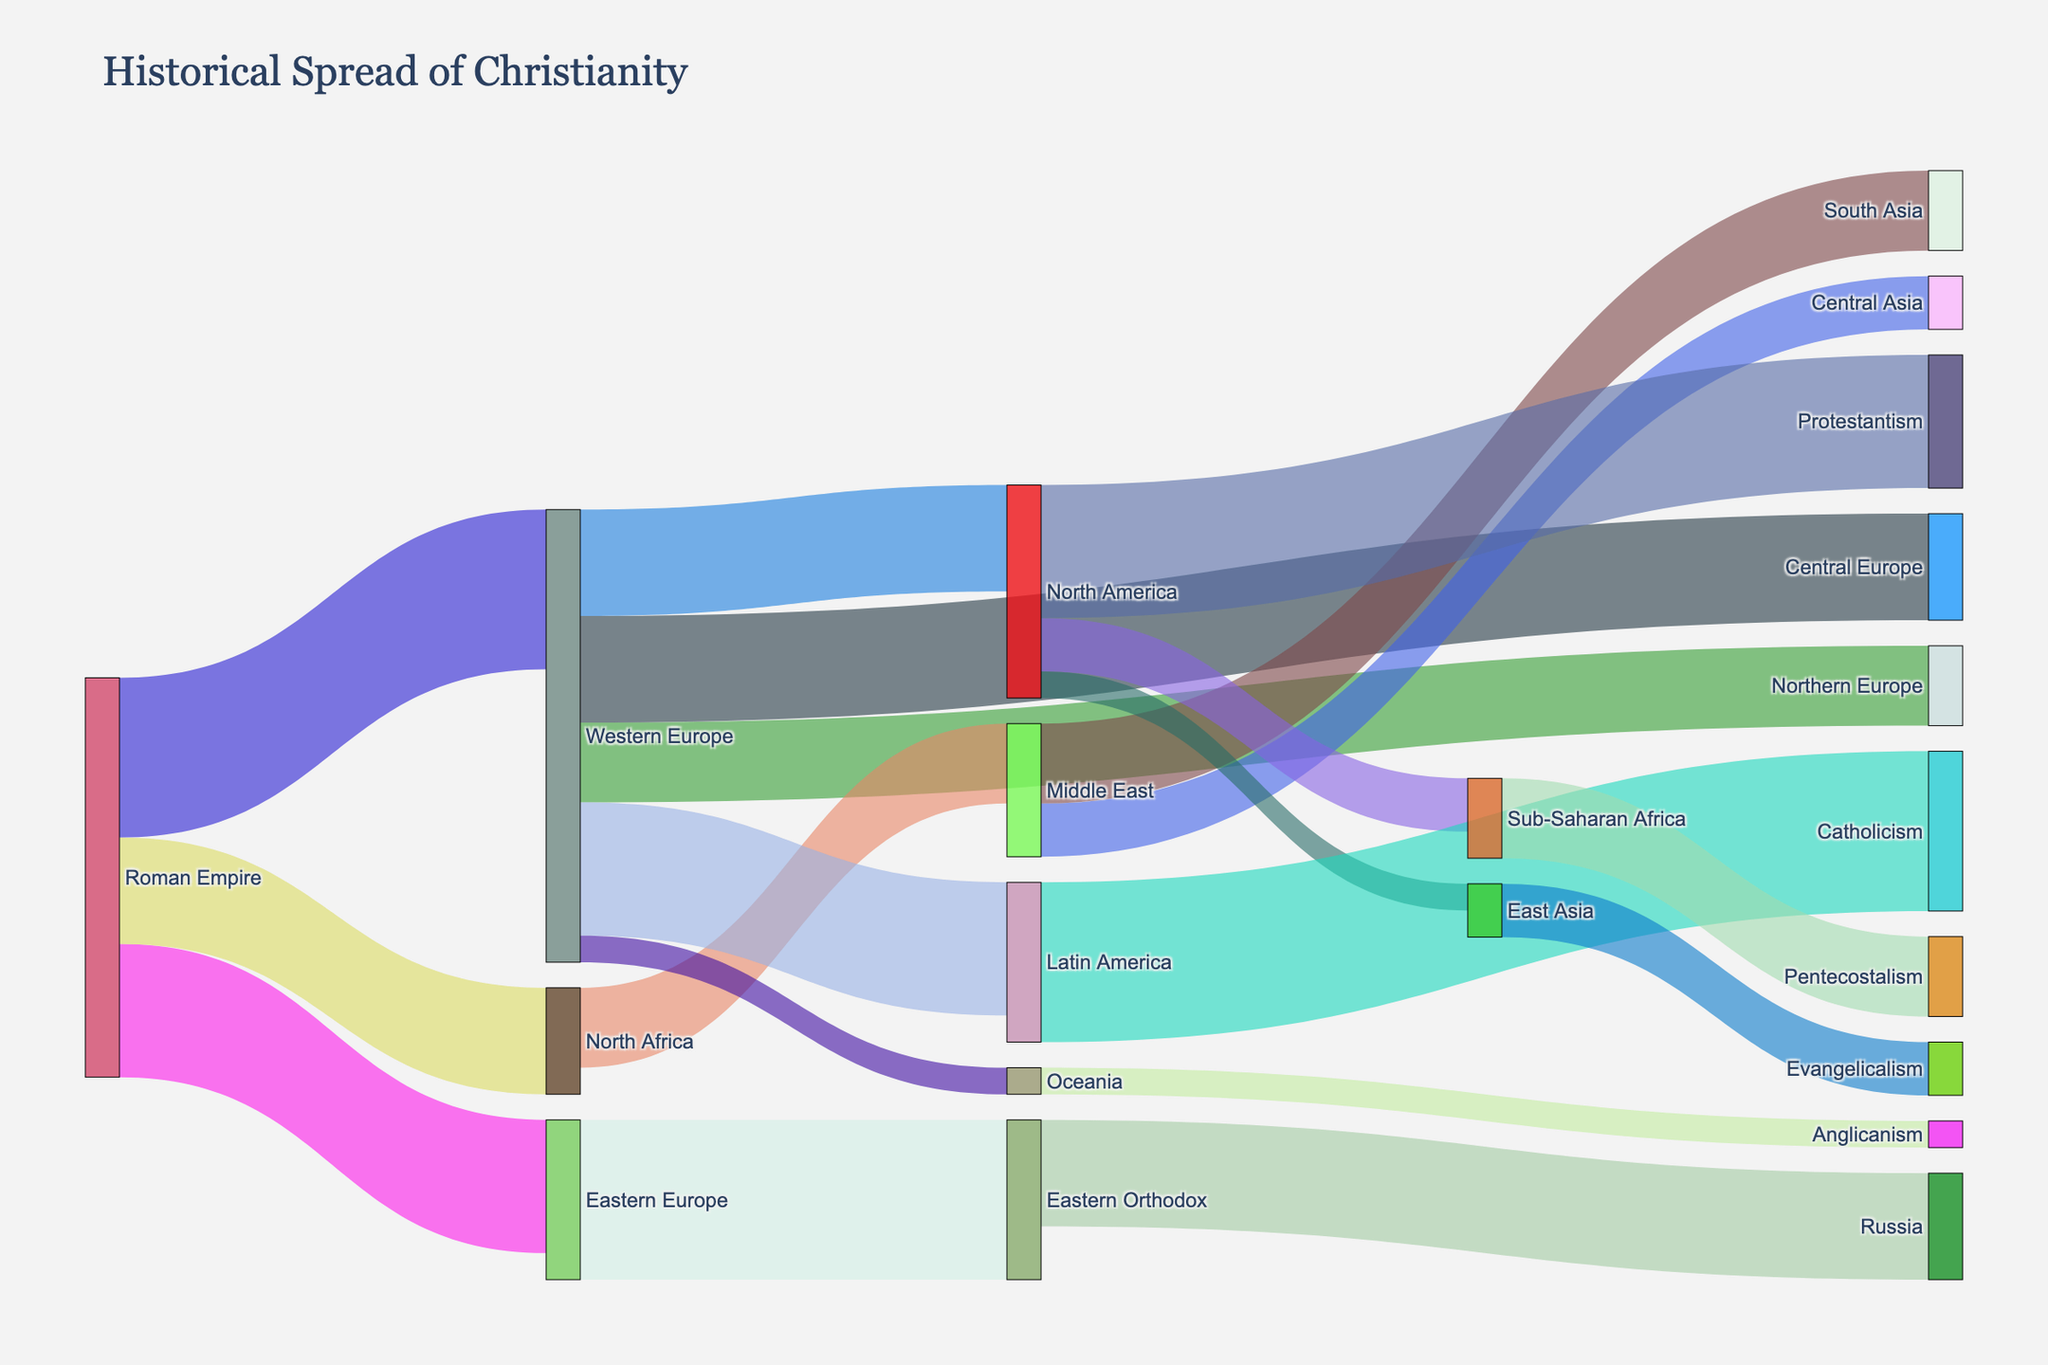What is the title of the figure? The title is usually displayed prominently at the top of the Sankey Diagram. It describes the main subject or focus of the figure.
Answer: Historical Spread of Christianity How many continents are shown in the diagram? By scanning through the nodes in the diagram, which are labeled with geographical areas, we can count the number of unique continents.
Answer: 6 (Western Europe, Eastern Europe, North Africa, Middle East, North America, Oceania) Which region received the largest number of followers from the Roman Empire? Look at the links originating from the 'Roman Empire' node and compare the values. The link with the highest value indicates the region that received the largest number of followers.
Answer: Western Europe What's the combined value of followers that moved from the Roman Empire to all other regions? Add up the values of all links emerging from the 'Roman Empire' node. The total represents the combined value of followers.
Answer: 75 (30 + 25 + 20) Compare the number of followers Western Europe sent to Northern and Central Europe. Which region received more? Look at the values of the links from Western Europe to Northern Europe and to Central Europe and compare them.
Answer: Central Europe How does the spread of Christianity in Latin America and North America differ in terms of denomination? Examine the final nodes tied to Latin America and North America to understand the type of denominations prevalent in each region.
Answer: Latin America (Catholicism), North America (Protestantism) What destination did Christianity spread to from North America? Identify the links that emerge from the 'North America' node and list the target nodes.
Answer: Sub-Saharan Africa, East Asia Which region became predominantly Eastern Orthodox? Look for the thickest link from the 'Eastern Europe' node and trace it to its destination.
Answer: Russia Count the number of followers that moved from the Middle East to other regions. What is the total value? Add up the values of all links originating from the 'Middle East' node to find the total.
Answer: 40 (15 + 10 + 15) What type of Christianity is dominant in Oceania? Identify the final node connected to the 'Oceania' node and its label to find the dominant denomination.
Answer: Anglicanism 